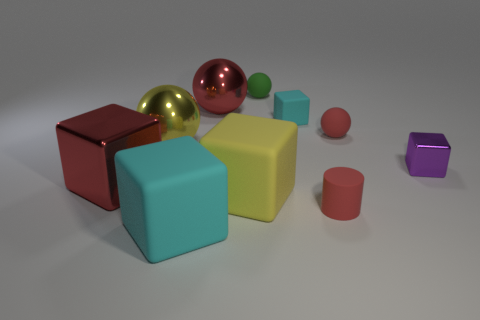What number of objects are big cyan objects or metallic things to the right of the green matte ball?
Your response must be concise. 2. What number of other things are there of the same shape as the small metal thing?
Provide a succinct answer. 4. Does the small sphere that is in front of the green rubber object have the same material as the small green ball?
Keep it short and to the point. Yes. What number of things are tiny metal balls or yellow objects?
Offer a very short reply. 2. What size is the yellow object that is the same shape as the purple metal thing?
Give a very brief answer. Large. How big is the yellow matte object?
Your answer should be very brief. Large. Is the number of tiny red matte balls in front of the tiny green sphere greater than the number of cyan metal cubes?
Make the answer very short. Yes. Is there anything else that is the same material as the large yellow ball?
Keep it short and to the point. Yes. There is a tiny rubber object in front of the big red metal cube; is it the same color as the shiny cube that is right of the red cube?
Ensure brevity in your answer.  No. There is a large yellow thing to the left of the large shiny ball on the right side of the large yellow thing that is behind the small purple metallic cube; what is it made of?
Offer a terse response. Metal. 